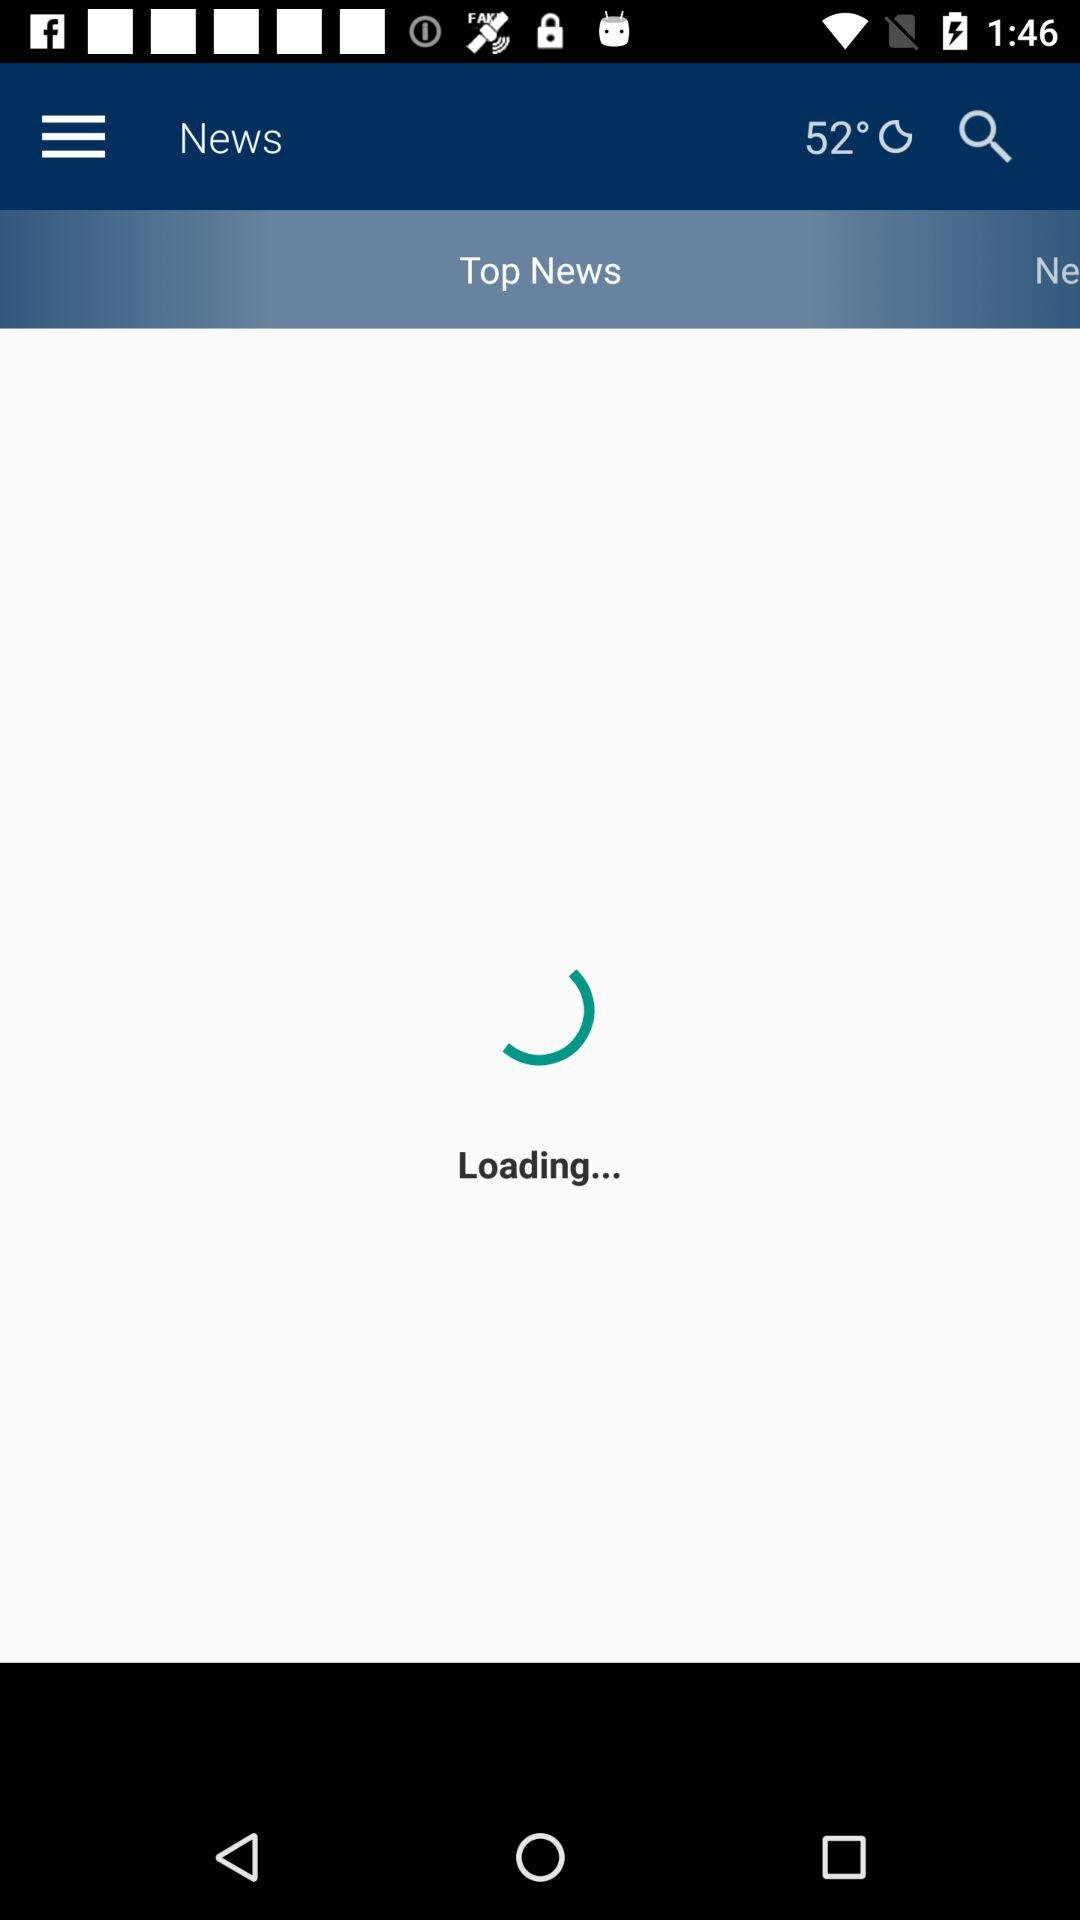How many degrees Celsius is it outside?
Answer the question using a single word or phrase. 52° C 